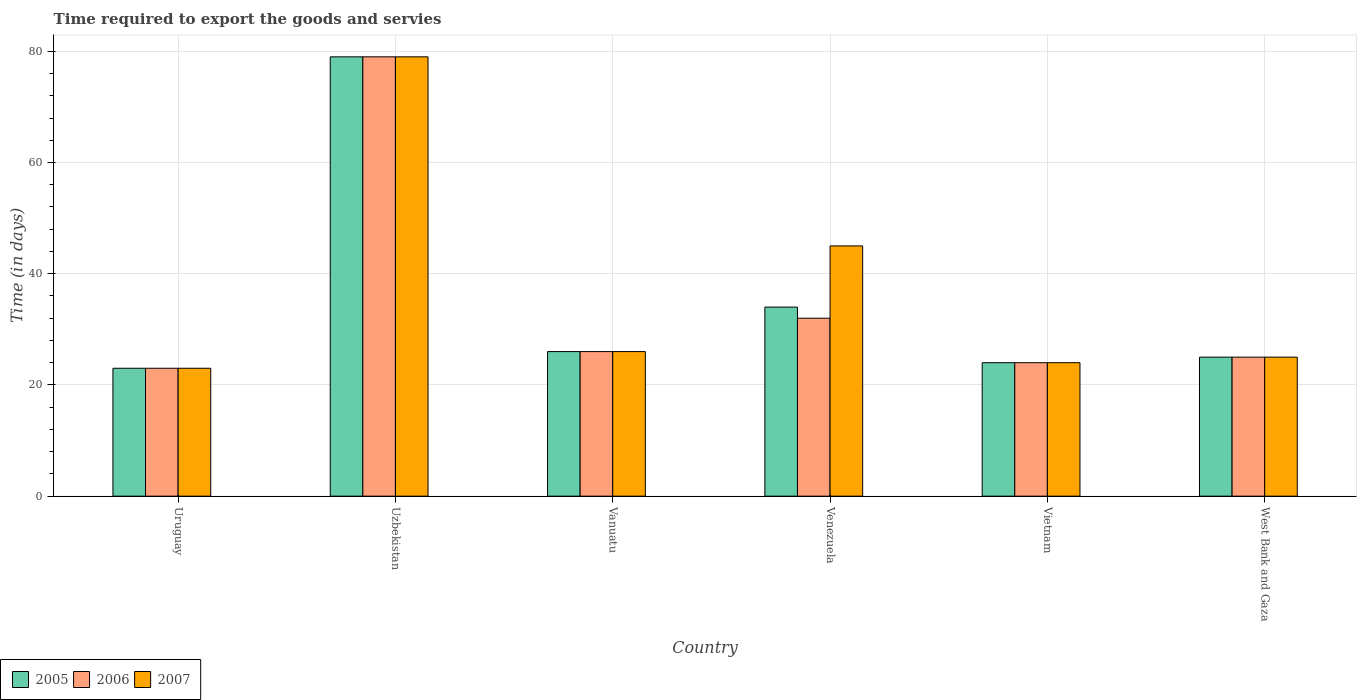How many different coloured bars are there?
Provide a succinct answer. 3. How many groups of bars are there?
Provide a short and direct response. 6. Are the number of bars on each tick of the X-axis equal?
Ensure brevity in your answer.  Yes. What is the label of the 4th group of bars from the left?
Provide a short and direct response. Venezuela. What is the number of days required to export the goods and services in 2006 in Uruguay?
Give a very brief answer. 23. Across all countries, what is the maximum number of days required to export the goods and services in 2005?
Provide a short and direct response. 79. Across all countries, what is the minimum number of days required to export the goods and services in 2005?
Keep it short and to the point. 23. In which country was the number of days required to export the goods and services in 2006 maximum?
Offer a very short reply. Uzbekistan. In which country was the number of days required to export the goods and services in 2007 minimum?
Your response must be concise. Uruguay. What is the total number of days required to export the goods and services in 2007 in the graph?
Provide a short and direct response. 222. What is the difference between the number of days required to export the goods and services in 2007 in Vanuatu and the number of days required to export the goods and services in 2006 in Uzbekistan?
Your answer should be very brief. -53. What is the ratio of the number of days required to export the goods and services in 2005 in Vietnam to that in West Bank and Gaza?
Your answer should be compact. 0.96. Is the number of days required to export the goods and services in 2005 in Uzbekistan less than that in Vietnam?
Your answer should be very brief. No. Is the difference between the number of days required to export the goods and services in 2005 in Uruguay and Vietnam greater than the difference between the number of days required to export the goods and services in 2007 in Uruguay and Vietnam?
Offer a terse response. No. What does the 1st bar from the left in Uruguay represents?
Provide a short and direct response. 2005. Is it the case that in every country, the sum of the number of days required to export the goods and services in 2005 and number of days required to export the goods and services in 2007 is greater than the number of days required to export the goods and services in 2006?
Ensure brevity in your answer.  Yes. How many bars are there?
Ensure brevity in your answer.  18. Does the graph contain grids?
Offer a terse response. Yes. Where does the legend appear in the graph?
Give a very brief answer. Bottom left. How are the legend labels stacked?
Provide a short and direct response. Horizontal. What is the title of the graph?
Make the answer very short. Time required to export the goods and servies. Does "1985" appear as one of the legend labels in the graph?
Your response must be concise. No. What is the label or title of the Y-axis?
Ensure brevity in your answer.  Time (in days). What is the Time (in days) of 2005 in Uruguay?
Provide a succinct answer. 23. What is the Time (in days) in 2005 in Uzbekistan?
Provide a succinct answer. 79. What is the Time (in days) of 2006 in Uzbekistan?
Provide a succinct answer. 79. What is the Time (in days) in 2007 in Uzbekistan?
Your response must be concise. 79. What is the Time (in days) of 2005 in Vanuatu?
Offer a very short reply. 26. What is the Time (in days) in 2006 in Vanuatu?
Your answer should be very brief. 26. What is the Time (in days) of 2005 in Vietnam?
Ensure brevity in your answer.  24. What is the Time (in days) of 2007 in Vietnam?
Provide a short and direct response. 24. What is the Time (in days) of 2007 in West Bank and Gaza?
Make the answer very short. 25. Across all countries, what is the maximum Time (in days) of 2005?
Provide a succinct answer. 79. Across all countries, what is the maximum Time (in days) of 2006?
Provide a short and direct response. 79. Across all countries, what is the maximum Time (in days) in 2007?
Offer a very short reply. 79. Across all countries, what is the minimum Time (in days) in 2005?
Offer a very short reply. 23. Across all countries, what is the minimum Time (in days) of 2007?
Make the answer very short. 23. What is the total Time (in days) of 2005 in the graph?
Make the answer very short. 211. What is the total Time (in days) in 2006 in the graph?
Keep it short and to the point. 209. What is the total Time (in days) in 2007 in the graph?
Offer a very short reply. 222. What is the difference between the Time (in days) in 2005 in Uruguay and that in Uzbekistan?
Your answer should be compact. -56. What is the difference between the Time (in days) of 2006 in Uruguay and that in Uzbekistan?
Offer a terse response. -56. What is the difference between the Time (in days) of 2007 in Uruguay and that in Uzbekistan?
Offer a very short reply. -56. What is the difference between the Time (in days) of 2005 in Uruguay and that in Vanuatu?
Your answer should be very brief. -3. What is the difference between the Time (in days) of 2006 in Uruguay and that in Vanuatu?
Your response must be concise. -3. What is the difference between the Time (in days) in 2007 in Uruguay and that in Vanuatu?
Provide a succinct answer. -3. What is the difference between the Time (in days) of 2006 in Uruguay and that in Venezuela?
Offer a terse response. -9. What is the difference between the Time (in days) of 2007 in Uruguay and that in Venezuela?
Provide a succinct answer. -22. What is the difference between the Time (in days) of 2005 in Uruguay and that in Vietnam?
Your answer should be compact. -1. What is the difference between the Time (in days) of 2005 in Uruguay and that in West Bank and Gaza?
Give a very brief answer. -2. What is the difference between the Time (in days) in 2007 in Uruguay and that in West Bank and Gaza?
Offer a very short reply. -2. What is the difference between the Time (in days) in 2005 in Uzbekistan and that in Vanuatu?
Your answer should be compact. 53. What is the difference between the Time (in days) in 2006 in Uzbekistan and that in Vanuatu?
Your answer should be compact. 53. What is the difference between the Time (in days) of 2007 in Uzbekistan and that in Vanuatu?
Give a very brief answer. 53. What is the difference between the Time (in days) of 2005 in Uzbekistan and that in Venezuela?
Offer a terse response. 45. What is the difference between the Time (in days) of 2007 in Uzbekistan and that in Venezuela?
Your answer should be very brief. 34. What is the difference between the Time (in days) in 2006 in Uzbekistan and that in Vietnam?
Keep it short and to the point. 55. What is the difference between the Time (in days) in 2005 in Uzbekistan and that in West Bank and Gaza?
Ensure brevity in your answer.  54. What is the difference between the Time (in days) in 2006 in Uzbekistan and that in West Bank and Gaza?
Your answer should be very brief. 54. What is the difference between the Time (in days) of 2007 in Uzbekistan and that in West Bank and Gaza?
Your answer should be compact. 54. What is the difference between the Time (in days) in 2005 in Vanuatu and that in Venezuela?
Provide a short and direct response. -8. What is the difference between the Time (in days) of 2007 in Vanuatu and that in Venezuela?
Your response must be concise. -19. What is the difference between the Time (in days) in 2006 in Vanuatu and that in Vietnam?
Offer a terse response. 2. What is the difference between the Time (in days) of 2005 in Vanuatu and that in West Bank and Gaza?
Offer a very short reply. 1. What is the difference between the Time (in days) of 2006 in Vanuatu and that in West Bank and Gaza?
Your answer should be compact. 1. What is the difference between the Time (in days) of 2007 in Vanuatu and that in West Bank and Gaza?
Ensure brevity in your answer.  1. What is the difference between the Time (in days) of 2006 in Venezuela and that in West Bank and Gaza?
Ensure brevity in your answer.  7. What is the difference between the Time (in days) of 2007 in Venezuela and that in West Bank and Gaza?
Offer a very short reply. 20. What is the difference between the Time (in days) in 2005 in Vietnam and that in West Bank and Gaza?
Provide a succinct answer. -1. What is the difference between the Time (in days) of 2006 in Vietnam and that in West Bank and Gaza?
Offer a very short reply. -1. What is the difference between the Time (in days) in 2005 in Uruguay and the Time (in days) in 2006 in Uzbekistan?
Offer a terse response. -56. What is the difference between the Time (in days) of 2005 in Uruguay and the Time (in days) of 2007 in Uzbekistan?
Make the answer very short. -56. What is the difference between the Time (in days) in 2006 in Uruguay and the Time (in days) in 2007 in Uzbekistan?
Provide a succinct answer. -56. What is the difference between the Time (in days) in 2006 in Uruguay and the Time (in days) in 2007 in Vanuatu?
Provide a short and direct response. -3. What is the difference between the Time (in days) in 2005 in Uruguay and the Time (in days) in 2006 in Venezuela?
Your answer should be very brief. -9. What is the difference between the Time (in days) in 2005 in Uruguay and the Time (in days) in 2007 in Venezuela?
Keep it short and to the point. -22. What is the difference between the Time (in days) of 2006 in Uruguay and the Time (in days) of 2007 in Vietnam?
Make the answer very short. -1. What is the difference between the Time (in days) in 2006 in Uzbekistan and the Time (in days) in 2007 in Vanuatu?
Provide a succinct answer. 53. What is the difference between the Time (in days) of 2005 in Uzbekistan and the Time (in days) of 2006 in Venezuela?
Make the answer very short. 47. What is the difference between the Time (in days) of 2005 in Uzbekistan and the Time (in days) of 2007 in Venezuela?
Offer a very short reply. 34. What is the difference between the Time (in days) of 2006 in Uzbekistan and the Time (in days) of 2007 in Venezuela?
Your answer should be very brief. 34. What is the difference between the Time (in days) in 2006 in Uzbekistan and the Time (in days) in 2007 in Vietnam?
Offer a very short reply. 55. What is the difference between the Time (in days) in 2005 in Uzbekistan and the Time (in days) in 2007 in West Bank and Gaza?
Ensure brevity in your answer.  54. What is the difference between the Time (in days) of 2006 in Vanuatu and the Time (in days) of 2007 in Venezuela?
Ensure brevity in your answer.  -19. What is the difference between the Time (in days) in 2005 in Vanuatu and the Time (in days) in 2007 in Vietnam?
Provide a succinct answer. 2. What is the difference between the Time (in days) of 2005 in Vanuatu and the Time (in days) of 2006 in West Bank and Gaza?
Offer a terse response. 1. What is the difference between the Time (in days) of 2006 in Vanuatu and the Time (in days) of 2007 in West Bank and Gaza?
Provide a short and direct response. 1. What is the difference between the Time (in days) of 2005 in Venezuela and the Time (in days) of 2007 in Vietnam?
Ensure brevity in your answer.  10. What is the difference between the Time (in days) in 2006 in Venezuela and the Time (in days) in 2007 in Vietnam?
Offer a terse response. 8. What is the difference between the Time (in days) of 2005 in Venezuela and the Time (in days) of 2006 in West Bank and Gaza?
Keep it short and to the point. 9. What is the difference between the Time (in days) in 2006 in Venezuela and the Time (in days) in 2007 in West Bank and Gaza?
Offer a very short reply. 7. What is the average Time (in days) in 2005 per country?
Your answer should be very brief. 35.17. What is the average Time (in days) in 2006 per country?
Your answer should be very brief. 34.83. What is the difference between the Time (in days) of 2005 and Time (in days) of 2006 in Uruguay?
Ensure brevity in your answer.  0. What is the difference between the Time (in days) of 2006 and Time (in days) of 2007 in Uruguay?
Provide a short and direct response. 0. What is the difference between the Time (in days) of 2005 and Time (in days) of 2006 in West Bank and Gaza?
Give a very brief answer. 0. What is the ratio of the Time (in days) in 2005 in Uruguay to that in Uzbekistan?
Offer a very short reply. 0.29. What is the ratio of the Time (in days) of 2006 in Uruguay to that in Uzbekistan?
Keep it short and to the point. 0.29. What is the ratio of the Time (in days) of 2007 in Uruguay to that in Uzbekistan?
Your answer should be compact. 0.29. What is the ratio of the Time (in days) in 2005 in Uruguay to that in Vanuatu?
Offer a terse response. 0.88. What is the ratio of the Time (in days) of 2006 in Uruguay to that in Vanuatu?
Offer a very short reply. 0.88. What is the ratio of the Time (in days) of 2007 in Uruguay to that in Vanuatu?
Provide a short and direct response. 0.88. What is the ratio of the Time (in days) in 2005 in Uruguay to that in Venezuela?
Offer a very short reply. 0.68. What is the ratio of the Time (in days) in 2006 in Uruguay to that in Venezuela?
Offer a terse response. 0.72. What is the ratio of the Time (in days) in 2007 in Uruguay to that in Venezuela?
Your response must be concise. 0.51. What is the ratio of the Time (in days) in 2005 in Uruguay to that in Vietnam?
Your response must be concise. 0.96. What is the ratio of the Time (in days) in 2006 in Uruguay to that in Vietnam?
Your answer should be compact. 0.96. What is the ratio of the Time (in days) of 2005 in Uruguay to that in West Bank and Gaza?
Ensure brevity in your answer.  0.92. What is the ratio of the Time (in days) in 2007 in Uruguay to that in West Bank and Gaza?
Provide a succinct answer. 0.92. What is the ratio of the Time (in days) of 2005 in Uzbekistan to that in Vanuatu?
Give a very brief answer. 3.04. What is the ratio of the Time (in days) of 2006 in Uzbekistan to that in Vanuatu?
Make the answer very short. 3.04. What is the ratio of the Time (in days) of 2007 in Uzbekistan to that in Vanuatu?
Keep it short and to the point. 3.04. What is the ratio of the Time (in days) of 2005 in Uzbekistan to that in Venezuela?
Provide a succinct answer. 2.32. What is the ratio of the Time (in days) of 2006 in Uzbekistan to that in Venezuela?
Make the answer very short. 2.47. What is the ratio of the Time (in days) of 2007 in Uzbekistan to that in Venezuela?
Your answer should be very brief. 1.76. What is the ratio of the Time (in days) of 2005 in Uzbekistan to that in Vietnam?
Ensure brevity in your answer.  3.29. What is the ratio of the Time (in days) of 2006 in Uzbekistan to that in Vietnam?
Your answer should be compact. 3.29. What is the ratio of the Time (in days) in 2007 in Uzbekistan to that in Vietnam?
Your answer should be very brief. 3.29. What is the ratio of the Time (in days) in 2005 in Uzbekistan to that in West Bank and Gaza?
Your answer should be very brief. 3.16. What is the ratio of the Time (in days) in 2006 in Uzbekistan to that in West Bank and Gaza?
Offer a terse response. 3.16. What is the ratio of the Time (in days) in 2007 in Uzbekistan to that in West Bank and Gaza?
Provide a succinct answer. 3.16. What is the ratio of the Time (in days) of 2005 in Vanuatu to that in Venezuela?
Offer a very short reply. 0.76. What is the ratio of the Time (in days) of 2006 in Vanuatu to that in Venezuela?
Keep it short and to the point. 0.81. What is the ratio of the Time (in days) of 2007 in Vanuatu to that in Venezuela?
Provide a short and direct response. 0.58. What is the ratio of the Time (in days) in 2005 in Vanuatu to that in Vietnam?
Make the answer very short. 1.08. What is the ratio of the Time (in days) of 2006 in Vanuatu to that in West Bank and Gaza?
Your answer should be compact. 1.04. What is the ratio of the Time (in days) of 2005 in Venezuela to that in Vietnam?
Offer a terse response. 1.42. What is the ratio of the Time (in days) of 2006 in Venezuela to that in Vietnam?
Your answer should be compact. 1.33. What is the ratio of the Time (in days) in 2007 in Venezuela to that in Vietnam?
Your answer should be very brief. 1.88. What is the ratio of the Time (in days) in 2005 in Venezuela to that in West Bank and Gaza?
Provide a short and direct response. 1.36. What is the ratio of the Time (in days) of 2006 in Venezuela to that in West Bank and Gaza?
Offer a terse response. 1.28. What is the ratio of the Time (in days) in 2007 in Venezuela to that in West Bank and Gaza?
Provide a short and direct response. 1.8. What is the ratio of the Time (in days) in 2005 in Vietnam to that in West Bank and Gaza?
Make the answer very short. 0.96. What is the ratio of the Time (in days) in 2006 in Vietnam to that in West Bank and Gaza?
Your answer should be compact. 0.96. What is the difference between the highest and the second highest Time (in days) of 2006?
Your answer should be compact. 47. What is the difference between the highest and the second highest Time (in days) in 2007?
Offer a terse response. 34. What is the difference between the highest and the lowest Time (in days) in 2007?
Give a very brief answer. 56. 